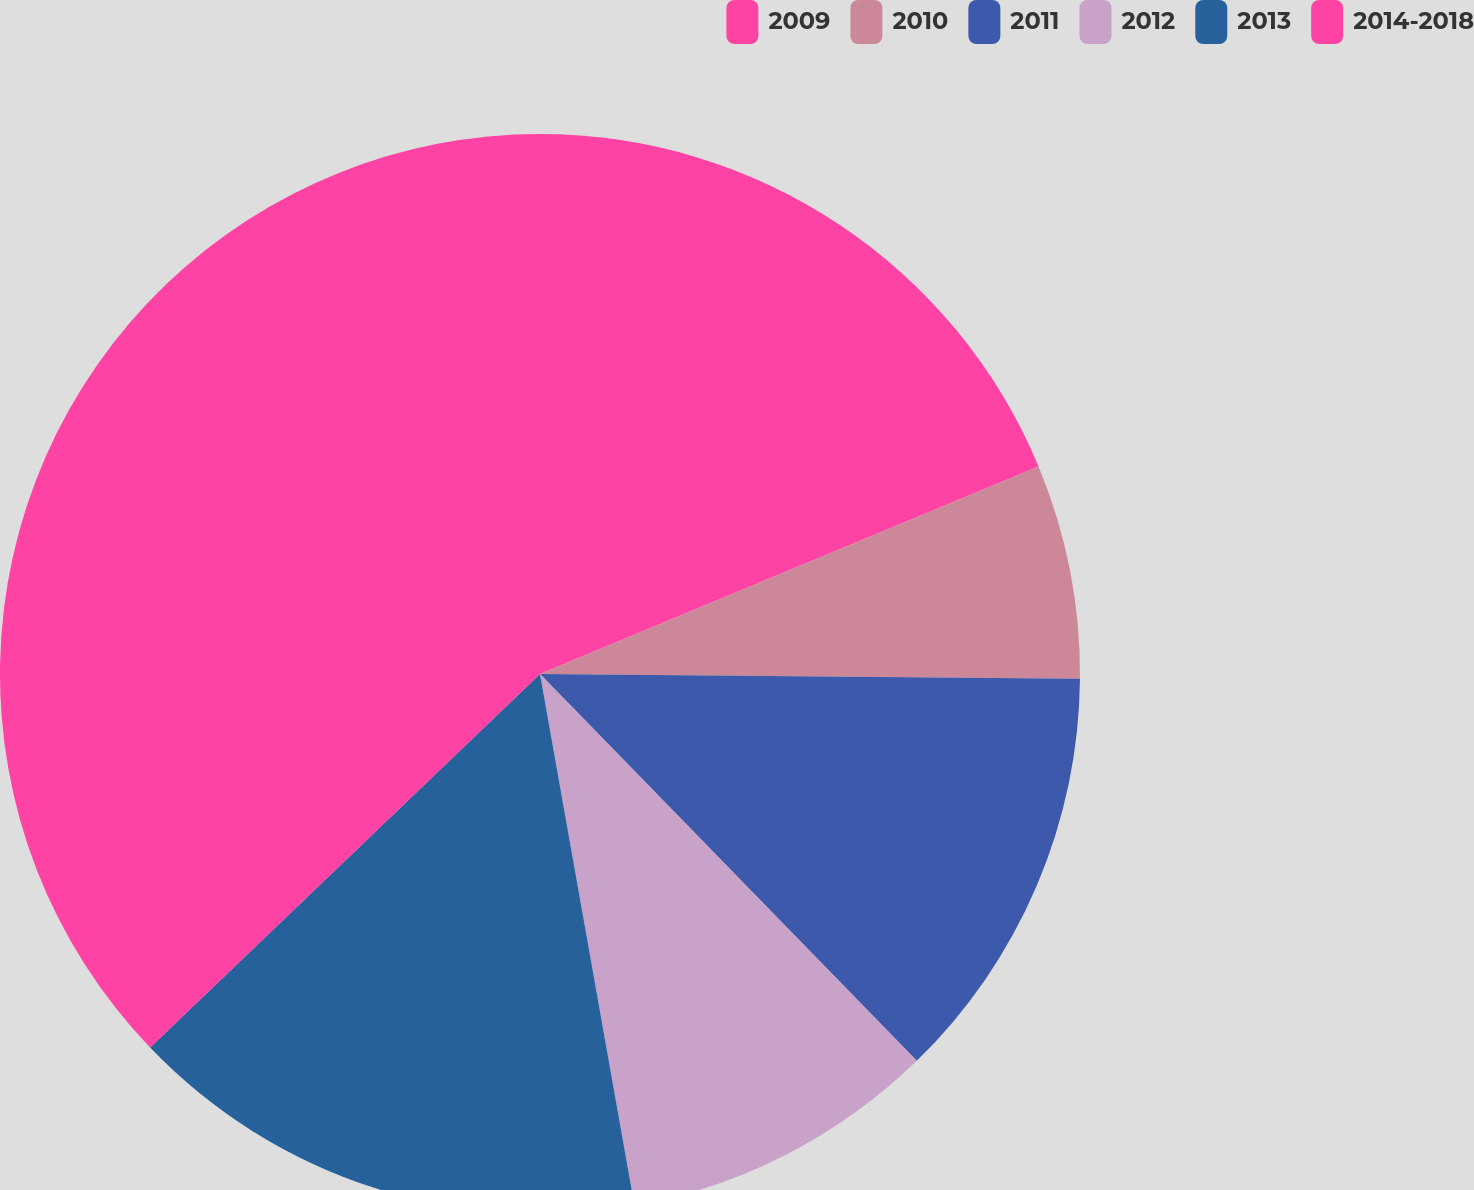Convert chart. <chart><loc_0><loc_0><loc_500><loc_500><pie_chart><fcel>2009<fcel>2010<fcel>2011<fcel>2012<fcel>2013<fcel>2014-2018<nl><fcel>18.72%<fcel>6.42%<fcel>12.57%<fcel>9.49%<fcel>15.64%<fcel>37.16%<nl></chart> 